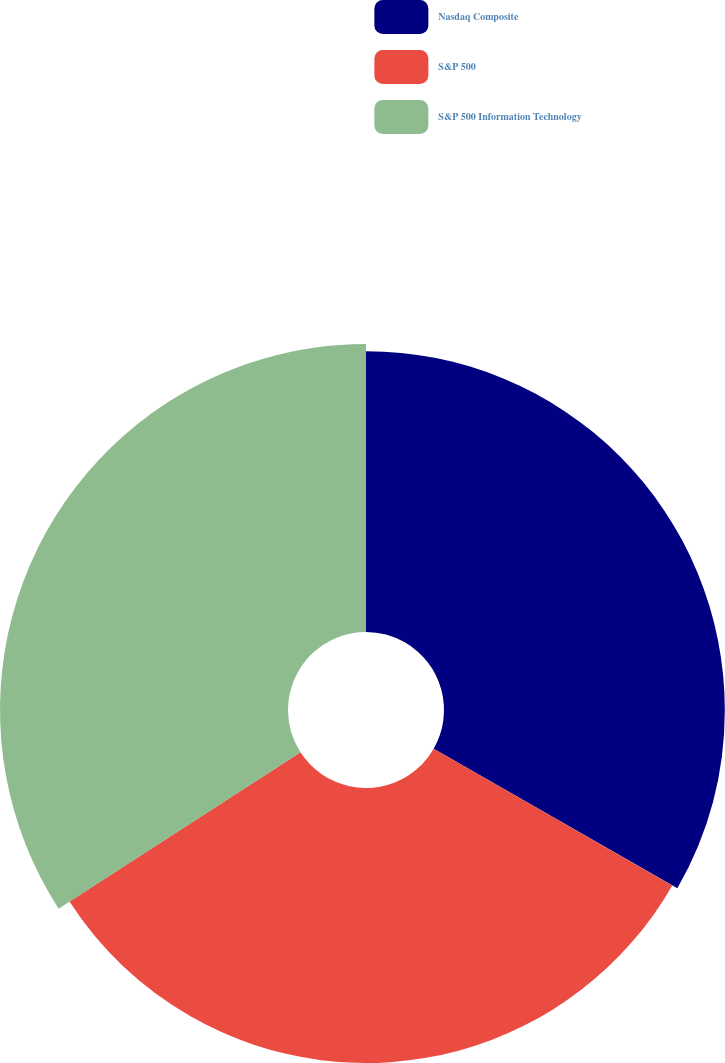<chart> <loc_0><loc_0><loc_500><loc_500><pie_chart><fcel>Nasdaq Composite<fcel>S&P 500<fcel>S&P 500 Information Technology<nl><fcel>33.28%<fcel>32.59%<fcel>34.13%<nl></chart> 